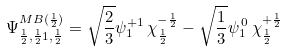<formula> <loc_0><loc_0><loc_500><loc_500>\Psi _ { \frac { 1 } { 2 } , \frac { 1 } { 2 } 1 , \frac { 1 } { 2 } } ^ { M B ( \frac { 1 } { 2 } ) } = \sqrt { \frac { 2 } { 3 } } \psi _ { 1 } ^ { + 1 } \, \chi _ { \frac { 1 } { 2 } } ^ { - \frac { 1 } { 2 } } - \sqrt { \frac { 1 } { 3 } } \psi _ { 1 } ^ { \, 0 } \, \chi _ { \frac { 1 } { 2 } } ^ { + \frac { 1 } { 2 } }</formula> 